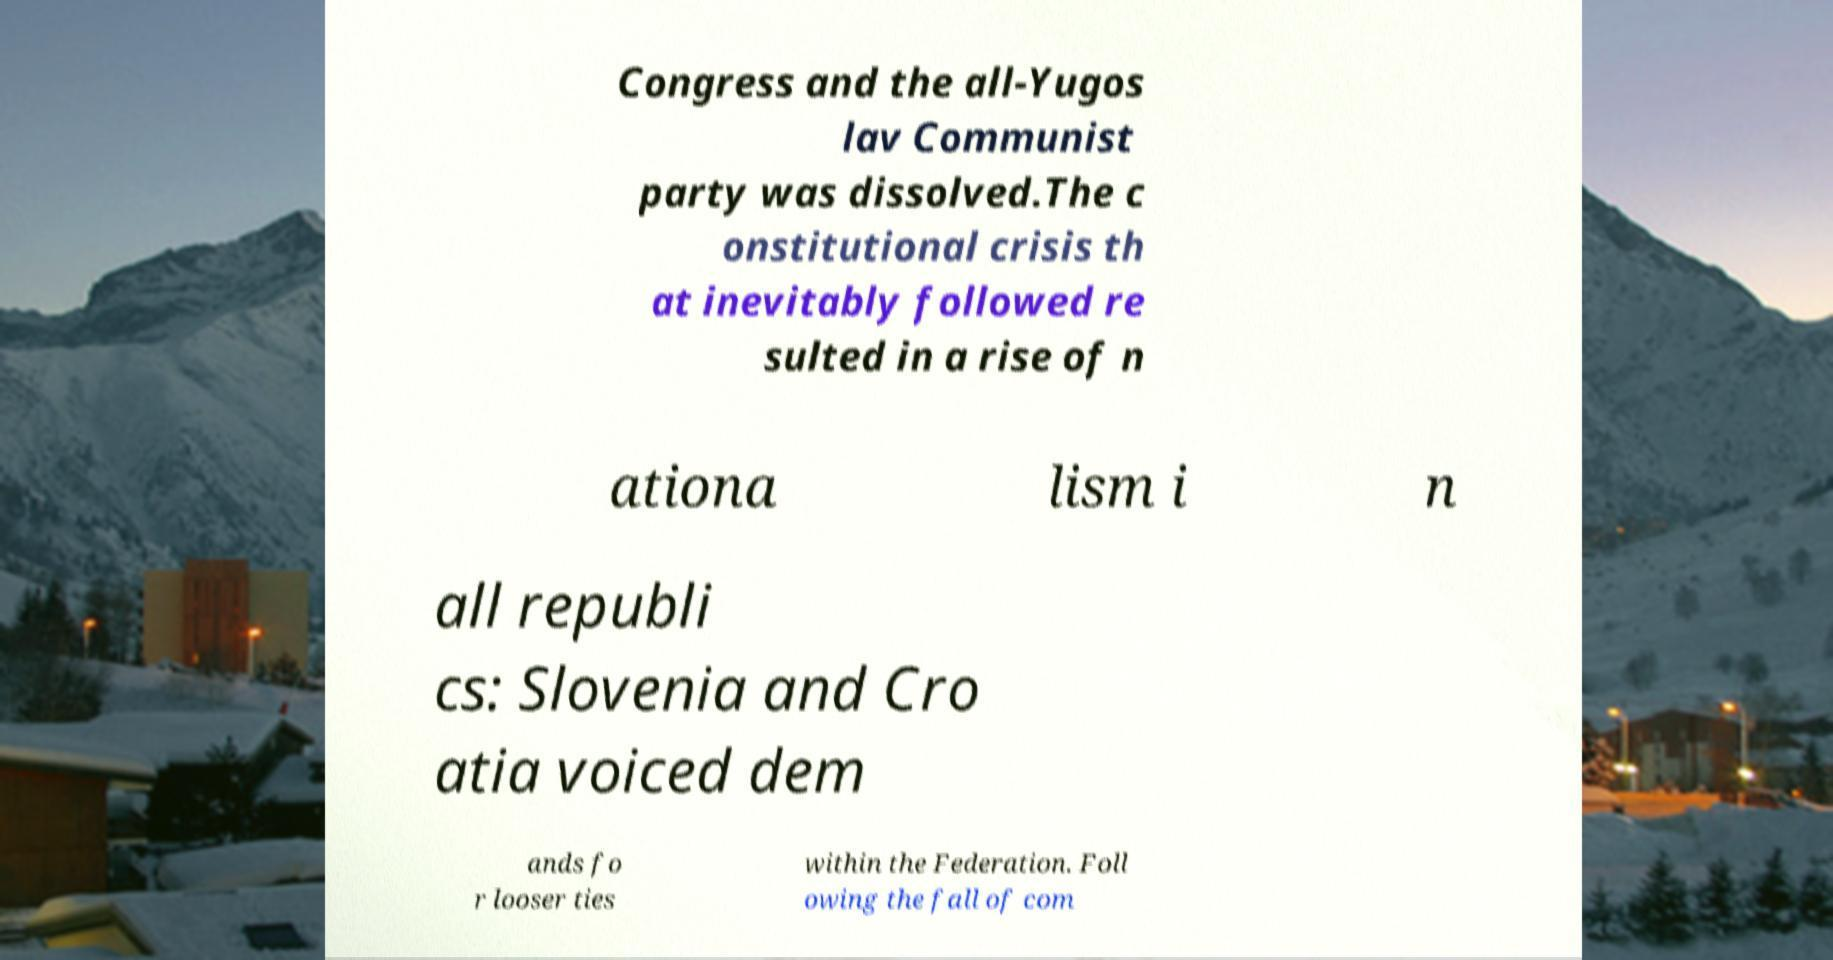Please read and relay the text visible in this image. What does it say? Congress and the all-Yugos lav Communist party was dissolved.The c onstitutional crisis th at inevitably followed re sulted in a rise of n ationa lism i n all republi cs: Slovenia and Cro atia voiced dem ands fo r looser ties within the Federation. Foll owing the fall of com 